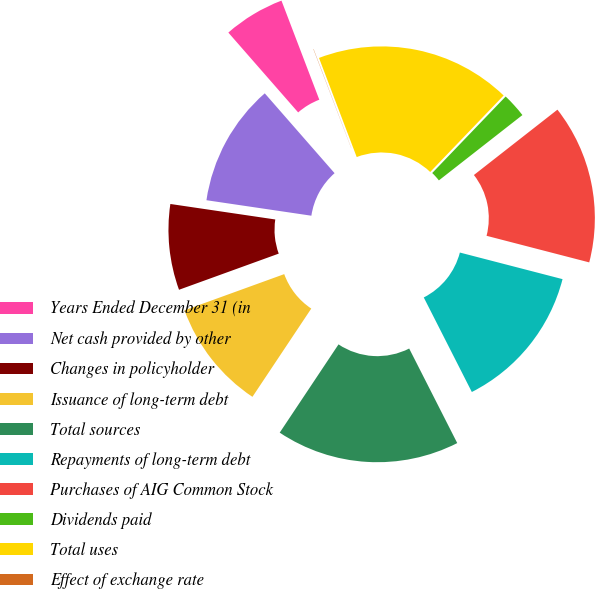Convert chart to OTSL. <chart><loc_0><loc_0><loc_500><loc_500><pie_chart><fcel>Years Ended December 31 (in<fcel>Net cash provided by other<fcel>Changes in policyholder<fcel>Issuance of long-term debt<fcel>Total sources<fcel>Repayments of long-term debt<fcel>Purchases of AIG Common Stock<fcel>Dividends paid<fcel>Total uses<fcel>Effect of exchange rate<nl><fcel>5.63%<fcel>11.23%<fcel>7.87%<fcel>10.11%<fcel>16.84%<fcel>13.48%<fcel>14.6%<fcel>2.26%<fcel>17.96%<fcel>0.02%<nl></chart> 